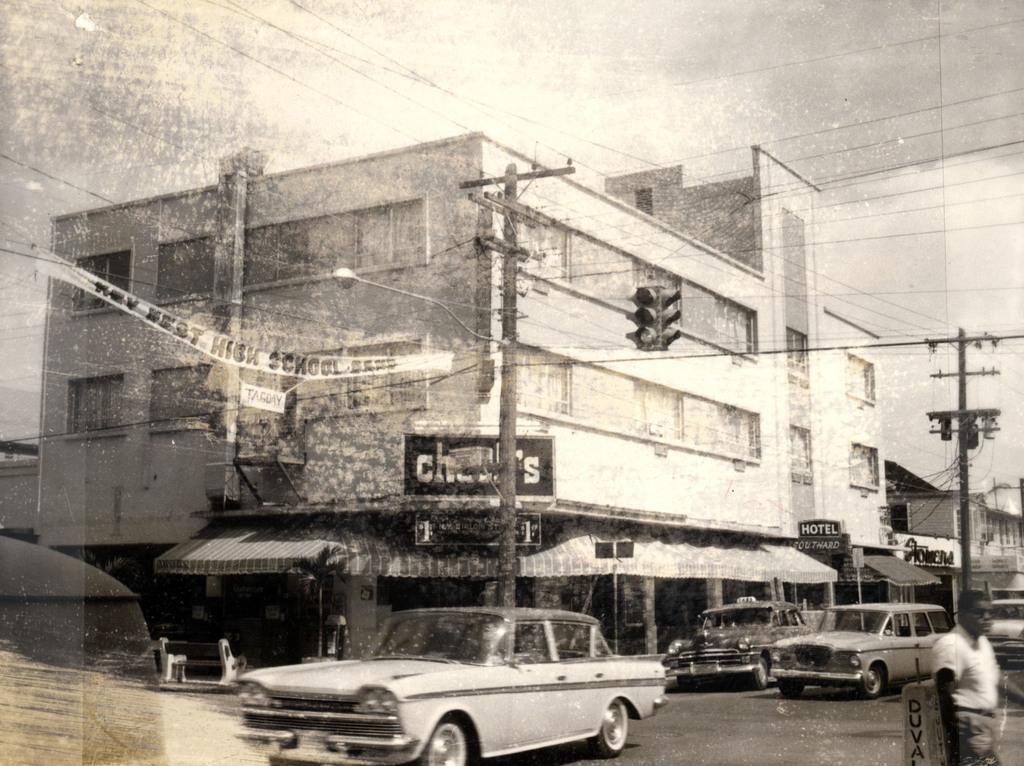Can you describe this image briefly? It is a black and white image. In this image we can see the buildings and electrical poles with wires. At the top there is sky and at the bottom we can see some vehicles passing on the road. There is also a person on the right. 